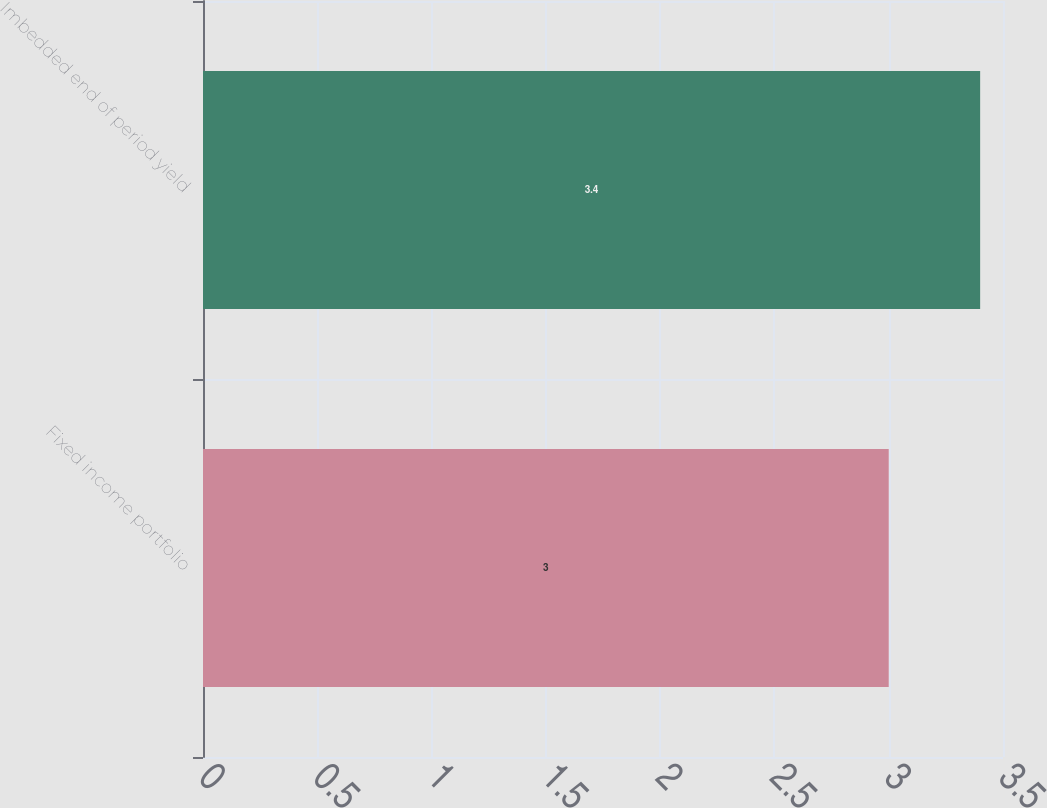<chart> <loc_0><loc_0><loc_500><loc_500><bar_chart><fcel>Fixed income portfolio<fcel>Imbedded end of period yield<nl><fcel>3<fcel>3.4<nl></chart> 